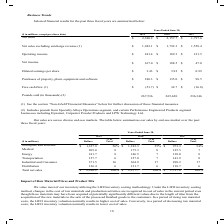According to Carpenter Technology's financial document, Where can further information on free cash flow and net sales excluding surcharge revenue be found? See the section “Non-GAAP Financial Measures”. The document states: "(1) See the section “Non-GAAP Financial Measures” below for further discussion of these financial measures...." Also, What does the amount of Pounds sold include? Includes pounds from Specialty Alloys Operations segment, and certain Performance Engineered Products segment businesses including Dynamet, Carpenter Powder Products and LPW Technology Ltd.. The document states: "(2) Includes pounds from Specialty Alloys Operations segment, and certain Performance Engineered Products segment businesses including Dynamet, Carpen..." Also, In which years was Net income calculated? The document contains multiple relevant values: 2019, 2018, 2017. From the document: "($ in millions, except per share data) 2019 2018 2017 Net sales $ 2,380.2 $ 2,157.7 $ 1,797.6 ($ in millions, except per share data) 2019 2018 2017 Ne..." Additionally, In which year was the diluted earnings per share largest? According to the financial document, 2018. The relevant text states: "($ in millions, except per share data) 2019 2018 2017 Net sales $ 2,380.2 $ 2,157.7 $ 1,797.6..." Also, can you calculate: What was the change in Purchases of property, plant, equipment and software in 2019 from 2018? Based on the calculation: 180.3-135.0, the result is 45.3 (in millions). This is based on the information: "ases of property, plant, equipment and software $ 180.3 $ 135.0 $ 98.5 property, plant, equipment and software $ 180.3 $ 135.0 $ 98.5..." The key data points involved are: 135.0, 180.3. Also, can you calculate: What was the percentage change in Purchases of property, plant, equipment and software in 2019 from 2018? To answer this question, I need to perform calculations using the financial data. The calculation is: (180.3-135.0)/135.0, which equals 33.56 (percentage). This is based on the information: "ases of property, plant, equipment and software $ 180.3 $ 135.0 $ 98.5 property, plant, equipment and software $ 180.3 $ 135.0 $ 98.5..." The key data points involved are: 135.0, 180.3. 